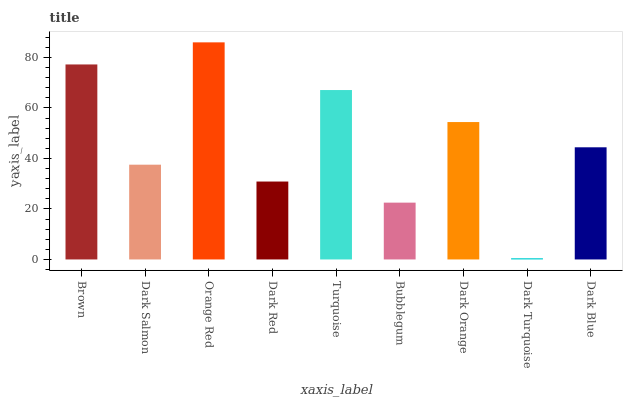Is Dark Turquoise the minimum?
Answer yes or no. Yes. Is Orange Red the maximum?
Answer yes or no. Yes. Is Dark Salmon the minimum?
Answer yes or no. No. Is Dark Salmon the maximum?
Answer yes or no. No. Is Brown greater than Dark Salmon?
Answer yes or no. Yes. Is Dark Salmon less than Brown?
Answer yes or no. Yes. Is Dark Salmon greater than Brown?
Answer yes or no. No. Is Brown less than Dark Salmon?
Answer yes or no. No. Is Dark Blue the high median?
Answer yes or no. Yes. Is Dark Blue the low median?
Answer yes or no. Yes. Is Brown the high median?
Answer yes or no. No. Is Turquoise the low median?
Answer yes or no. No. 